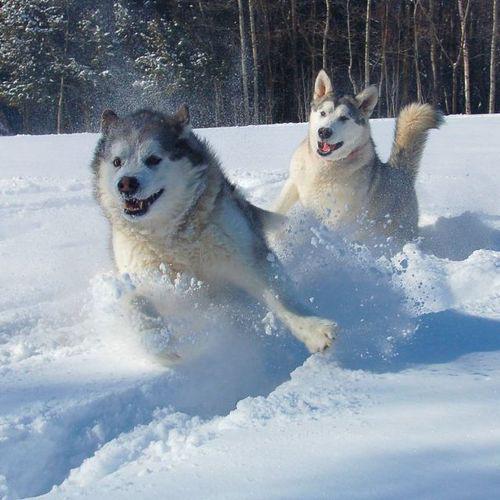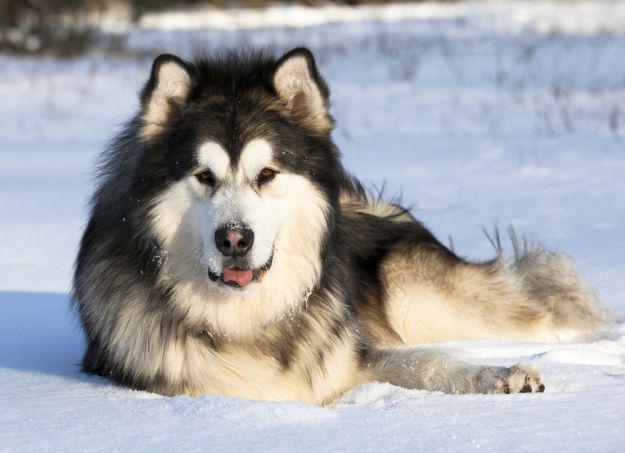The first image is the image on the left, the second image is the image on the right. For the images shown, is this caption "Each image shows a line of at least four dogs heading in one direction, and at least one image shows dogs on a surface that is not covered in snow." true? Answer yes or no. No. The first image is the image on the left, the second image is the image on the right. Evaluate the accuracy of this statement regarding the images: "There is a single dog in the snow in one image.". Is it true? Answer yes or no. Yes. 